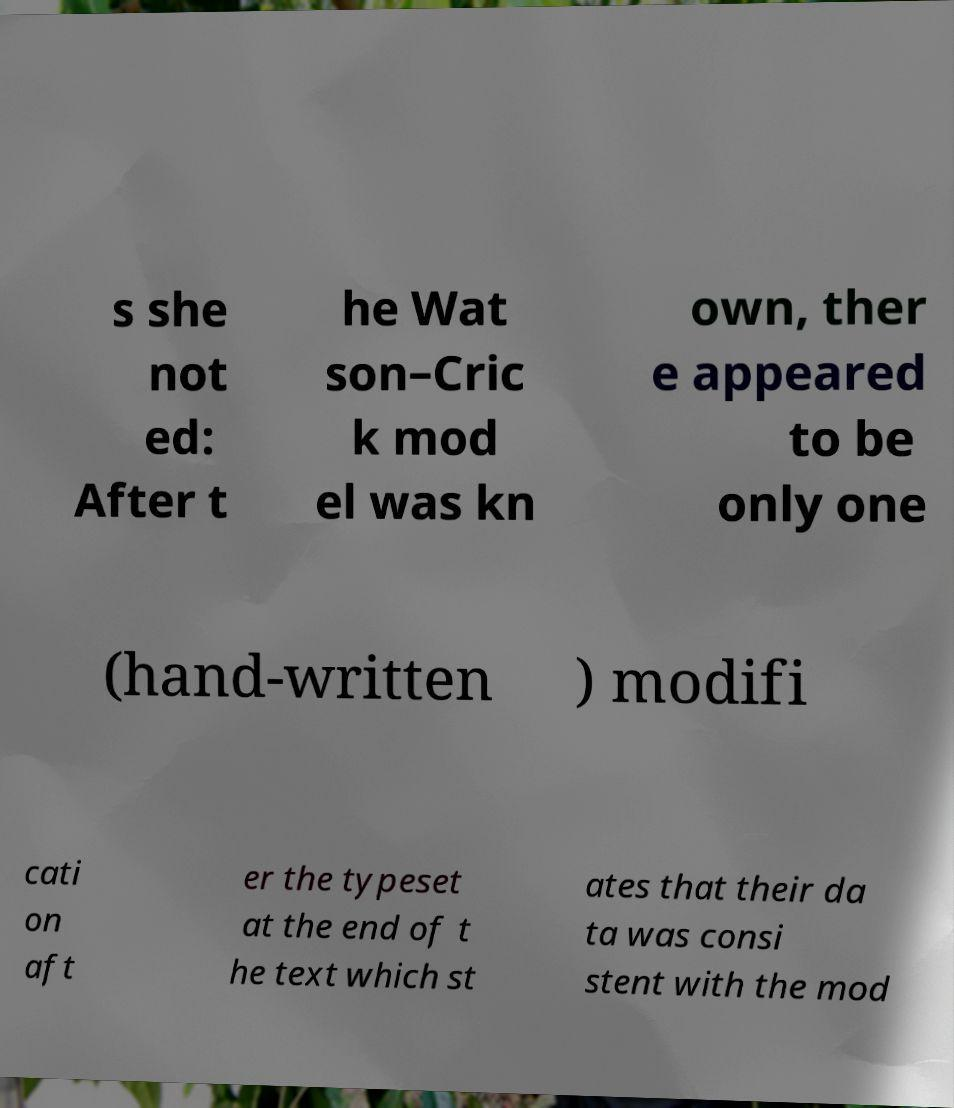I need the written content from this picture converted into text. Can you do that? s she not ed: After t he Wat son–Cric k mod el was kn own, ther e appeared to be only one (hand-written ) modifi cati on aft er the typeset at the end of t he text which st ates that their da ta was consi stent with the mod 